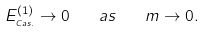Convert formula to latex. <formula><loc_0><loc_0><loc_500><loc_500>E ^ { ( 1 ) } _ { _ { C a s . } } \rightarrow 0 \quad a s \quad m \rightarrow 0 .</formula> 